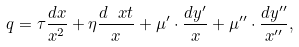Convert formula to latex. <formula><loc_0><loc_0><loc_500><loc_500>q = \tau \frac { d x } { x ^ { 2 } } + \eta \frac { d \ x t } { x } + \mu ^ { \prime } \cdot \frac { d y ^ { \prime } } { x } + \mu ^ { \prime \prime } \cdot \frac { d y ^ { \prime \prime } } { x ^ { \prime \prime } } ,</formula> 